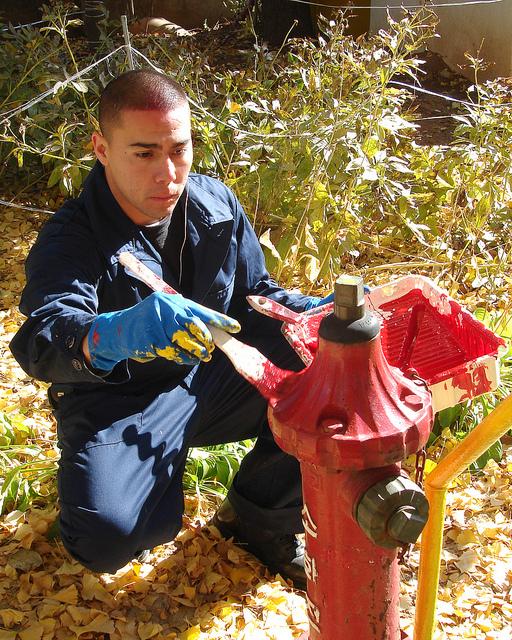Are the man's gloves full of paint?
Concise answer only. Yes. What hand is the man using to paint the fire hydrate?
Keep it brief. Right. What hairstyle does the man have?
Be succinct. Shaved. 